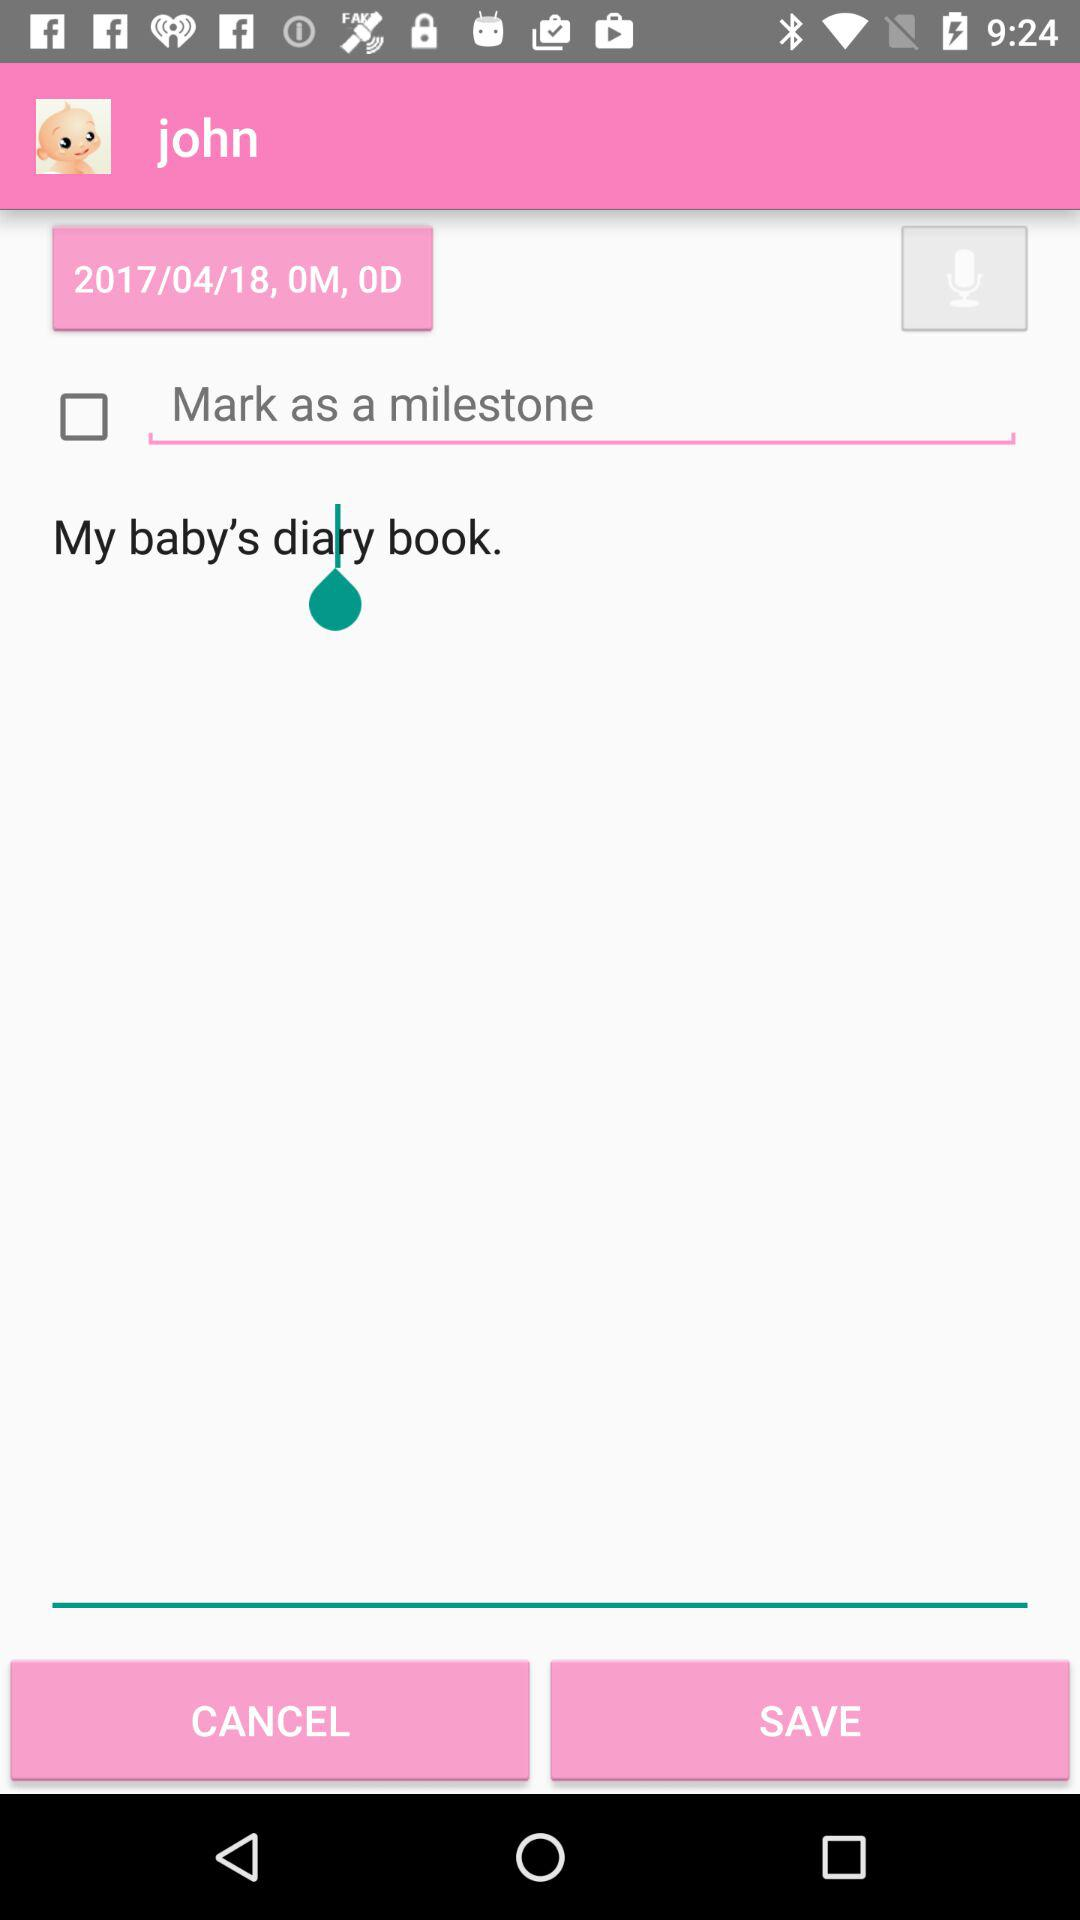What is the status of the "Mark as a milestone"? The status is "off". 